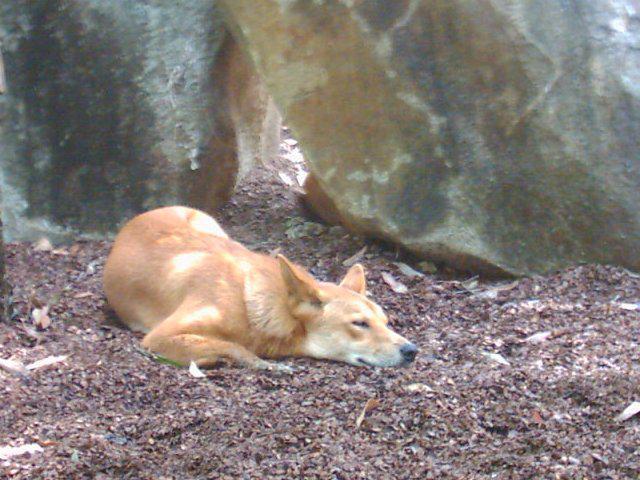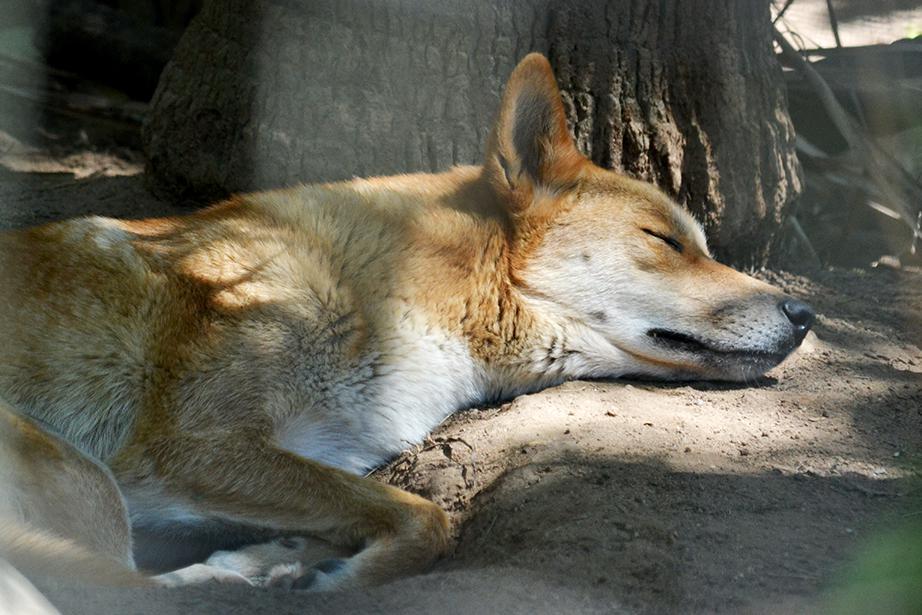The first image is the image on the left, the second image is the image on the right. Assess this claim about the two images: "One of the images shows a dog laying near a tree.". Correct or not? Answer yes or no. Yes. The first image is the image on the left, the second image is the image on the right. Assess this claim about the two images: "Each image shows one reclining orange dingo with its eyes closed and its head down instead of raised, and no dingos are tiny pups.". Correct or not? Answer yes or no. Yes. 